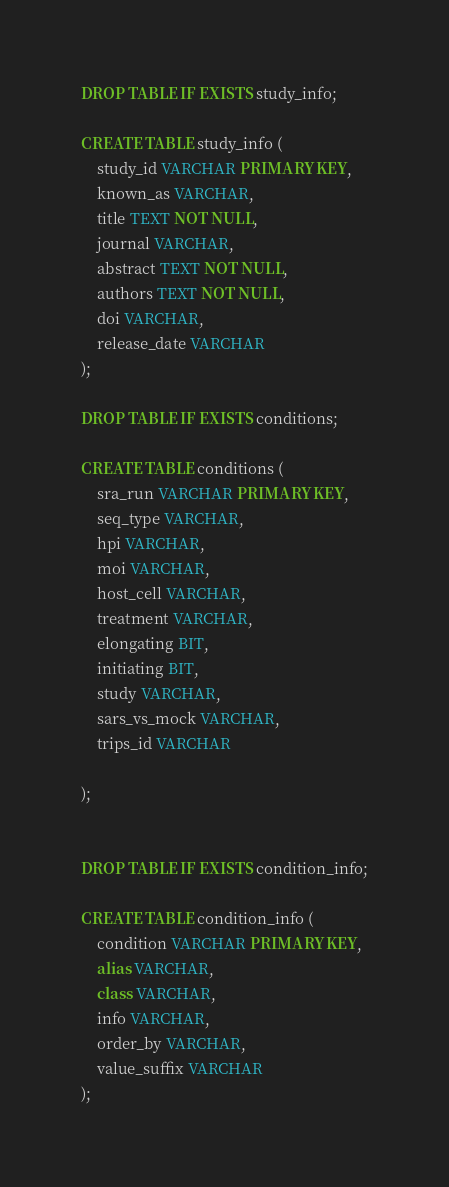Convert code to text. <code><loc_0><loc_0><loc_500><loc_500><_SQL_>DROP TABLE IF EXISTS study_info;

CREATE TABLE study_info (
    study_id VARCHAR PRIMARY KEY,
    known_as VARCHAR,
    title TEXT NOT NULL,
    journal VARCHAR,
    abstract TEXT NOT NULL,
    authors TEXT NOT NULL,
    doi VARCHAR,
    release_date VARCHAR
);

DROP TABLE IF EXISTS conditions;

CREATE TABLE conditions (
    sra_run VARCHAR PRIMARY KEY,
    seq_type VARCHAR,
    hpi VARCHAR,
    moi VARCHAR,
    host_cell VARCHAR,
    treatment VARCHAR,
    elongating BIT,
    initiating BIT,
    study VARCHAR,
    sars_vs_mock VARCHAR, 
    trips_id VARCHAR

);


DROP TABLE IF EXISTS condition_info;

CREATE TABLE condition_info (
    condition VARCHAR PRIMARY KEY,
    alias VARCHAR,
    class VARCHAR,
    info VARCHAR,
    order_by VARCHAR,
    value_suffix VARCHAR
);   
</code> 